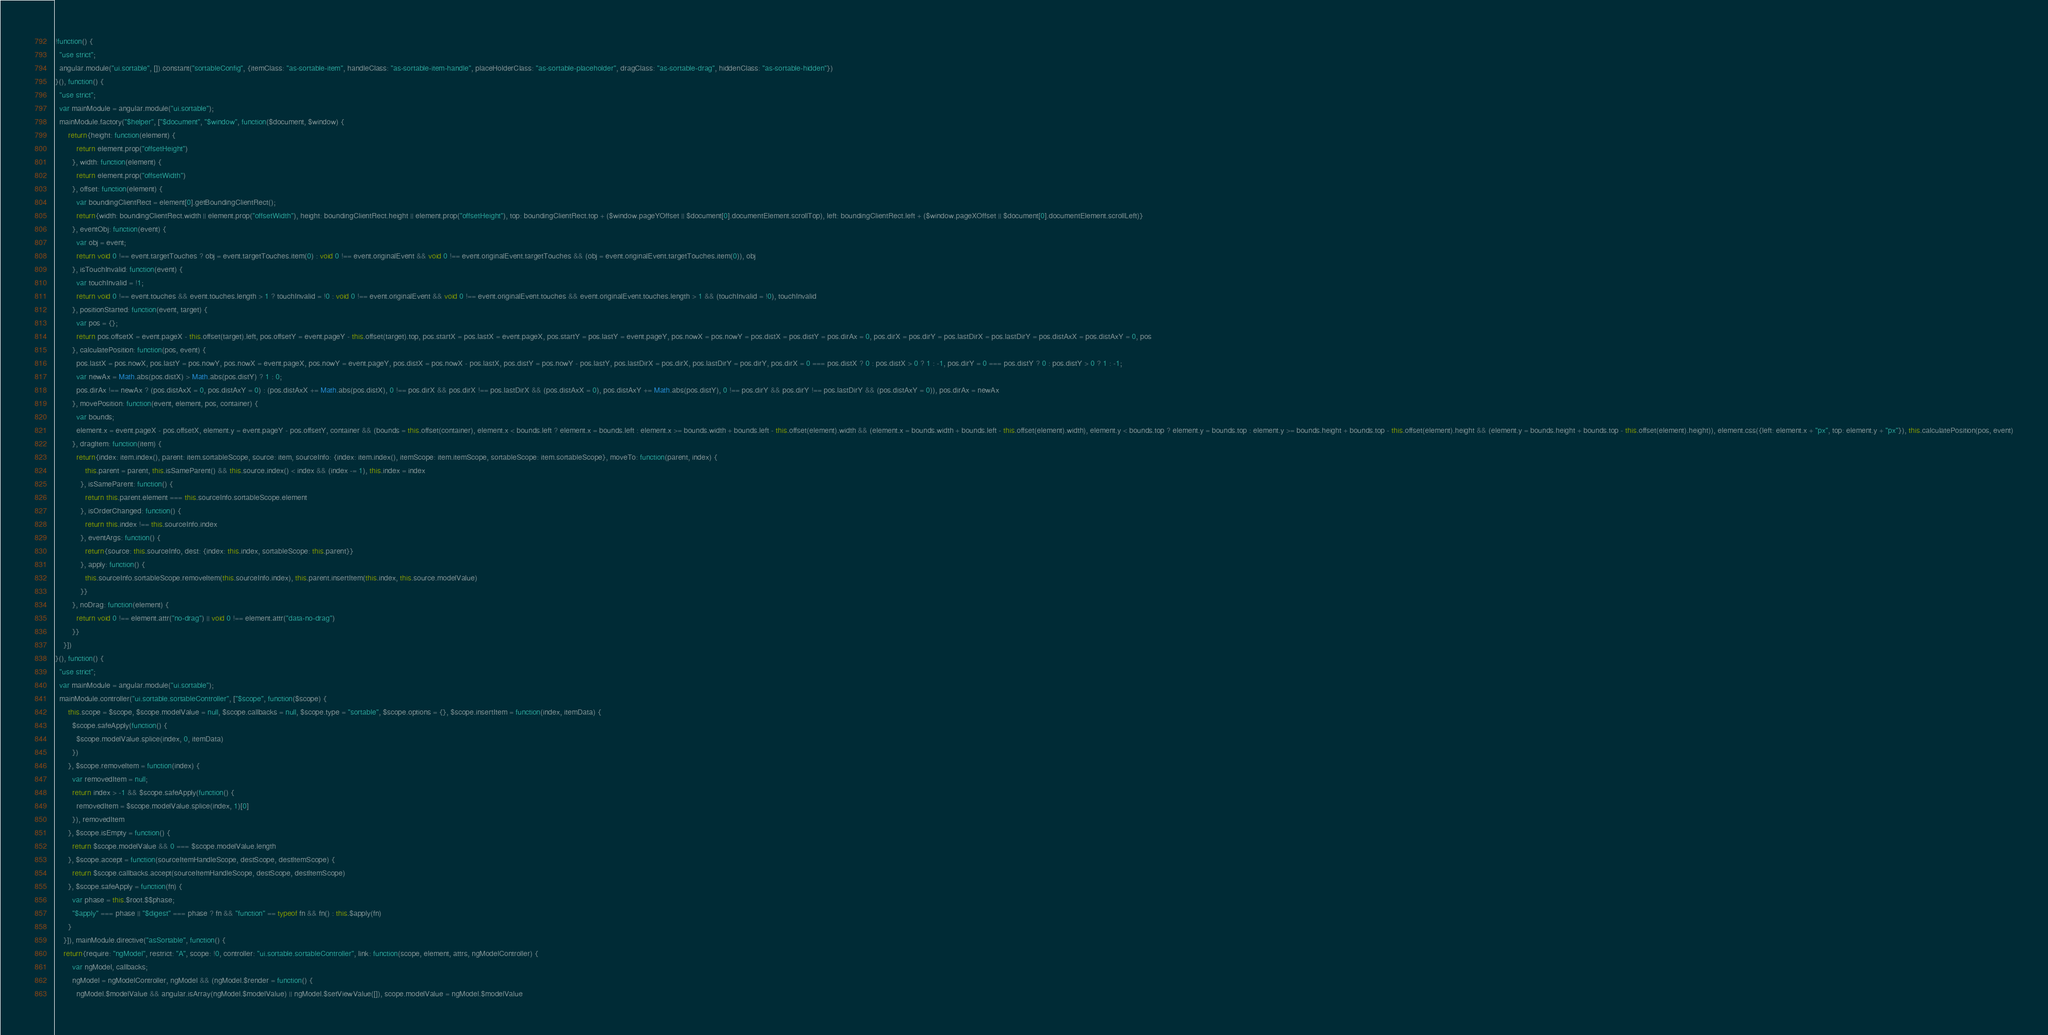Convert code to text. <code><loc_0><loc_0><loc_500><loc_500><_JavaScript_>!function() {
  "use strict";
  angular.module("ui.sortable", []).constant("sortableConfig", {itemClass: "as-sortable-item", handleClass: "as-sortable-item-handle", placeHolderClass: "as-sortable-placeholder", dragClass: "as-sortable-drag", hiddenClass: "as-sortable-hidden"})
}(), function() {
  "use strict";
  var mainModule = angular.module("ui.sortable");
  mainModule.factory("$helper", ["$document", "$window", function($document, $window) {
      return{height: function(element) {
          return element.prop("offsetHeight")
        }, width: function(element) {
          return element.prop("offsetWidth")
        }, offset: function(element) {
          var boundingClientRect = element[0].getBoundingClientRect();
          return{width: boundingClientRect.width || element.prop("offsetWidth"), height: boundingClientRect.height || element.prop("offsetHeight"), top: boundingClientRect.top + ($window.pageYOffset || $document[0].documentElement.scrollTop), left: boundingClientRect.left + ($window.pageXOffset || $document[0].documentElement.scrollLeft)}
        }, eventObj: function(event) {
          var obj = event;
          return void 0 !== event.targetTouches ? obj = event.targetTouches.item(0) : void 0 !== event.originalEvent && void 0 !== event.originalEvent.targetTouches && (obj = event.originalEvent.targetTouches.item(0)), obj
        }, isTouchInvalid: function(event) {
          var touchInvalid = !1;
          return void 0 !== event.touches && event.touches.length > 1 ? touchInvalid = !0 : void 0 !== event.originalEvent && void 0 !== event.originalEvent.touches && event.originalEvent.touches.length > 1 && (touchInvalid = !0), touchInvalid
        }, positionStarted: function(event, target) {
          var pos = {};
          return pos.offsetX = event.pageX - this.offset(target).left, pos.offsetY = event.pageY - this.offset(target).top, pos.startX = pos.lastX = event.pageX, pos.startY = pos.lastY = event.pageY, pos.nowX = pos.nowY = pos.distX = pos.distY = pos.dirAx = 0, pos.dirX = pos.dirY = pos.lastDirX = pos.lastDirY = pos.distAxX = pos.distAxY = 0, pos
        }, calculatePosition: function(pos, event) {
          pos.lastX = pos.nowX, pos.lastY = pos.nowY, pos.nowX = event.pageX, pos.nowY = event.pageY, pos.distX = pos.nowX - pos.lastX, pos.distY = pos.nowY - pos.lastY, pos.lastDirX = pos.dirX, pos.lastDirY = pos.dirY, pos.dirX = 0 === pos.distX ? 0 : pos.distX > 0 ? 1 : -1, pos.dirY = 0 === pos.distY ? 0 : pos.distY > 0 ? 1 : -1;
          var newAx = Math.abs(pos.distX) > Math.abs(pos.distY) ? 1 : 0;
          pos.dirAx !== newAx ? (pos.distAxX = 0, pos.distAxY = 0) : (pos.distAxX += Math.abs(pos.distX), 0 !== pos.dirX && pos.dirX !== pos.lastDirX && (pos.distAxX = 0), pos.distAxY += Math.abs(pos.distY), 0 !== pos.dirY && pos.dirY !== pos.lastDirY && (pos.distAxY = 0)), pos.dirAx = newAx
        }, movePosition: function(event, element, pos, container) {
          var bounds;
          element.x = event.pageX - pos.offsetX, element.y = event.pageY - pos.offsetY, container && (bounds = this.offset(container), element.x < bounds.left ? element.x = bounds.left : element.x >= bounds.width + bounds.left - this.offset(element).width && (element.x = bounds.width + bounds.left - this.offset(element).width), element.y < bounds.top ? element.y = bounds.top : element.y >= bounds.height + bounds.top - this.offset(element).height && (element.y = bounds.height + bounds.top - this.offset(element).height)), element.css({left: element.x + "px", top: element.y + "px"}), this.calculatePosition(pos, event)
        }, dragItem: function(item) {
          return{index: item.index(), parent: item.sortableScope, source: item, sourceInfo: {index: item.index(), itemScope: item.itemScope, sortableScope: item.sortableScope}, moveTo: function(parent, index) {
              this.parent = parent, this.isSameParent() && this.source.index() < index && (index -= 1), this.index = index
            }, isSameParent: function() {
              return this.parent.element === this.sourceInfo.sortableScope.element
            }, isOrderChanged: function() {
              return this.index !== this.sourceInfo.index
            }, eventArgs: function() {
              return{source: this.sourceInfo, dest: {index: this.index, sortableScope: this.parent}}
            }, apply: function() {
              this.sourceInfo.sortableScope.removeItem(this.sourceInfo.index), this.parent.insertItem(this.index, this.source.modelValue)
            }}
        }, noDrag: function(element) {
          return void 0 !== element.attr("no-drag") || void 0 !== element.attr("data-no-drag")
        }}
    }])
}(), function() {
  "use strict";
  var mainModule = angular.module("ui.sortable");
  mainModule.controller("ui.sortable.sortableController", ["$scope", function($scope) {
      this.scope = $scope, $scope.modelValue = null, $scope.callbacks = null, $scope.type = "sortable", $scope.options = {}, $scope.insertItem = function(index, itemData) {
        $scope.safeApply(function() {
          $scope.modelValue.splice(index, 0, itemData)
        })
      }, $scope.removeItem = function(index) {
        var removedItem = null;
        return index > -1 && $scope.safeApply(function() {
          removedItem = $scope.modelValue.splice(index, 1)[0]
        }), removedItem
      }, $scope.isEmpty = function() {
        return $scope.modelValue && 0 === $scope.modelValue.length
      }, $scope.accept = function(sourceItemHandleScope, destScope, destItemScope) {
        return $scope.callbacks.accept(sourceItemHandleScope, destScope, destItemScope)
      }, $scope.safeApply = function(fn) {
        var phase = this.$root.$$phase;
        "$apply" === phase || "$digest" === phase ? fn && "function" == typeof fn && fn() : this.$apply(fn)
      }
    }]), mainModule.directive("asSortable", function() {
    return{require: "ngModel", restrict: "A", scope: !0, controller: "ui.sortable.sortableController", link: function(scope, element, attrs, ngModelController) {
        var ngModel, callbacks;
        ngModel = ngModelController, ngModel && (ngModel.$render = function() {
          ngModel.$modelValue && angular.isArray(ngModel.$modelValue) || ngModel.$setViewValue([]), scope.modelValue = ngModel.$modelValue</code> 